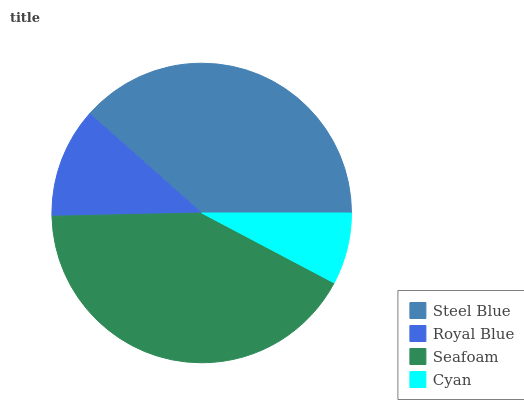Is Cyan the minimum?
Answer yes or no. Yes. Is Seafoam the maximum?
Answer yes or no. Yes. Is Royal Blue the minimum?
Answer yes or no. No. Is Royal Blue the maximum?
Answer yes or no. No. Is Steel Blue greater than Royal Blue?
Answer yes or no. Yes. Is Royal Blue less than Steel Blue?
Answer yes or no. Yes. Is Royal Blue greater than Steel Blue?
Answer yes or no. No. Is Steel Blue less than Royal Blue?
Answer yes or no. No. Is Steel Blue the high median?
Answer yes or no. Yes. Is Royal Blue the low median?
Answer yes or no. Yes. Is Royal Blue the high median?
Answer yes or no. No. Is Seafoam the low median?
Answer yes or no. No. 